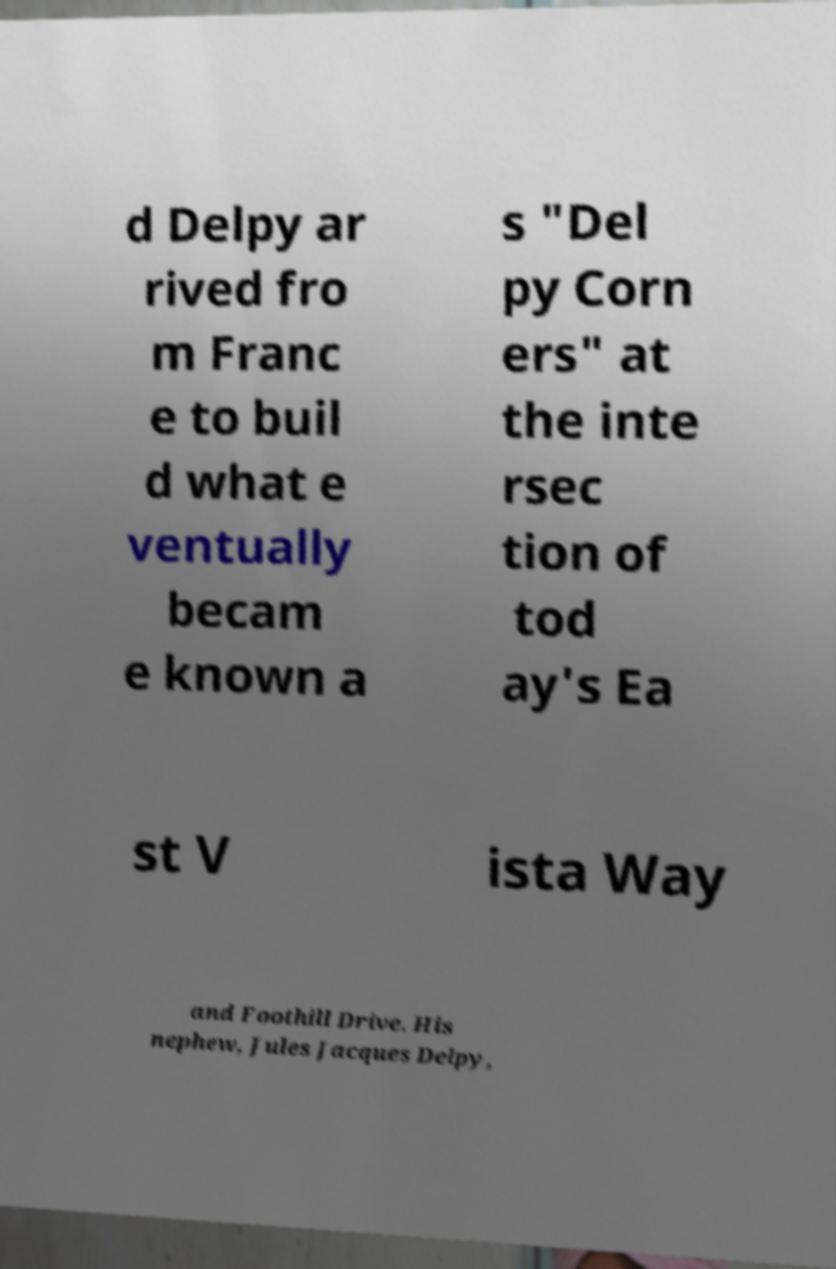Please identify and transcribe the text found in this image. d Delpy ar rived fro m Franc e to buil d what e ventually becam e known a s "Del py Corn ers" at the inte rsec tion of tod ay's Ea st V ista Way and Foothill Drive. His nephew, Jules Jacques Delpy, 